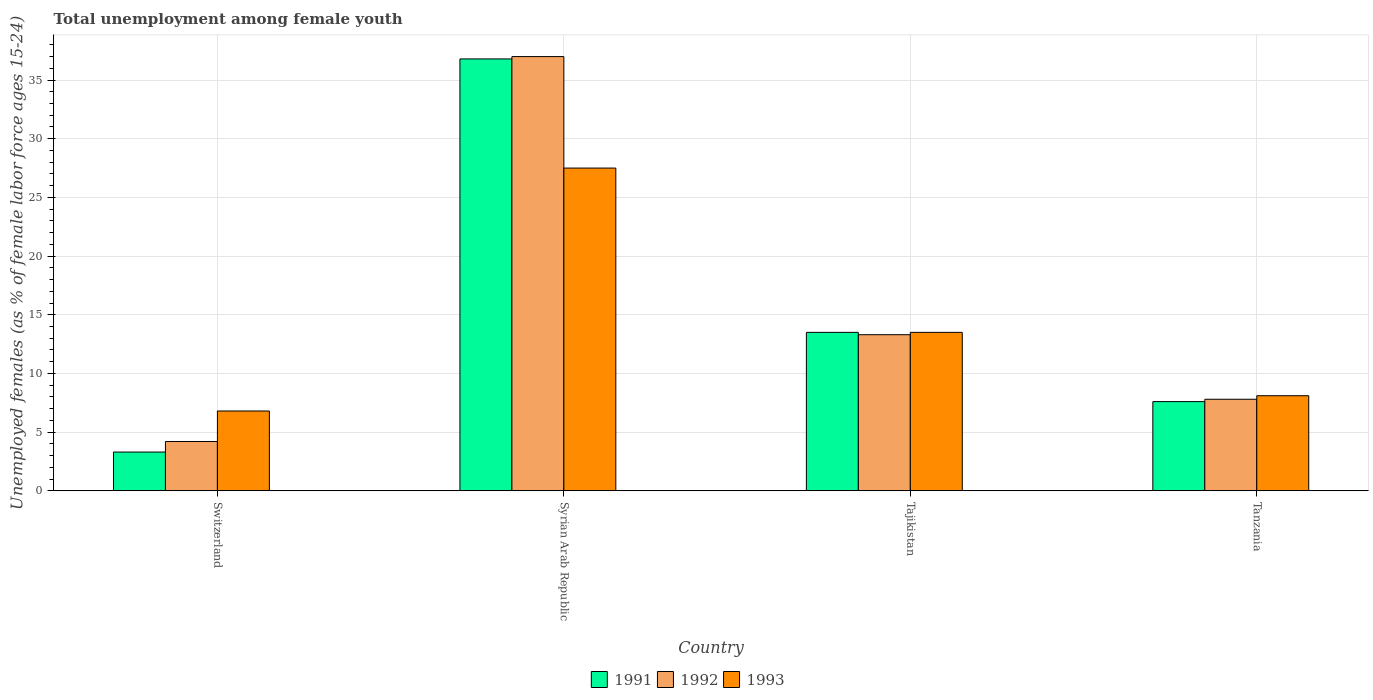How many different coloured bars are there?
Ensure brevity in your answer.  3. How many groups of bars are there?
Make the answer very short. 4. Are the number of bars per tick equal to the number of legend labels?
Offer a terse response. Yes. Are the number of bars on each tick of the X-axis equal?
Your answer should be compact. Yes. How many bars are there on the 3rd tick from the left?
Keep it short and to the point. 3. How many bars are there on the 1st tick from the right?
Provide a short and direct response. 3. What is the label of the 4th group of bars from the left?
Ensure brevity in your answer.  Tanzania. In how many cases, is the number of bars for a given country not equal to the number of legend labels?
Provide a short and direct response. 0. What is the percentage of unemployed females in in 1992 in Tanzania?
Offer a very short reply. 7.8. Across all countries, what is the maximum percentage of unemployed females in in 1992?
Make the answer very short. 37. Across all countries, what is the minimum percentage of unemployed females in in 1991?
Give a very brief answer. 3.3. In which country was the percentage of unemployed females in in 1991 maximum?
Your answer should be very brief. Syrian Arab Republic. In which country was the percentage of unemployed females in in 1991 minimum?
Your answer should be compact. Switzerland. What is the total percentage of unemployed females in in 1992 in the graph?
Make the answer very short. 62.3. What is the difference between the percentage of unemployed females in in 1992 in Tajikistan and the percentage of unemployed females in in 1991 in Tanzania?
Your answer should be very brief. 5.7. What is the average percentage of unemployed females in in 1991 per country?
Offer a very short reply. 15.3. What is the difference between the percentage of unemployed females in of/in 1993 and percentage of unemployed females in of/in 1992 in Tanzania?
Ensure brevity in your answer.  0.3. What is the ratio of the percentage of unemployed females in in 1993 in Switzerland to that in Tajikistan?
Give a very brief answer. 0.5. Is the percentage of unemployed females in in 1992 in Syrian Arab Republic less than that in Tajikistan?
Offer a very short reply. No. What is the difference between the highest and the second highest percentage of unemployed females in in 1992?
Make the answer very short. -23.7. What is the difference between the highest and the lowest percentage of unemployed females in in 1991?
Ensure brevity in your answer.  33.5. In how many countries, is the percentage of unemployed females in in 1993 greater than the average percentage of unemployed females in in 1993 taken over all countries?
Offer a terse response. 1. Is the sum of the percentage of unemployed females in in 1992 in Switzerland and Syrian Arab Republic greater than the maximum percentage of unemployed females in in 1993 across all countries?
Offer a terse response. Yes. What does the 2nd bar from the left in Tanzania represents?
Provide a succinct answer. 1992. How many bars are there?
Offer a terse response. 12. Does the graph contain any zero values?
Provide a short and direct response. No. Where does the legend appear in the graph?
Make the answer very short. Bottom center. What is the title of the graph?
Offer a very short reply. Total unemployment among female youth. Does "2013" appear as one of the legend labels in the graph?
Your answer should be very brief. No. What is the label or title of the X-axis?
Your response must be concise. Country. What is the label or title of the Y-axis?
Offer a very short reply. Unemployed females (as % of female labor force ages 15-24). What is the Unemployed females (as % of female labor force ages 15-24) in 1991 in Switzerland?
Ensure brevity in your answer.  3.3. What is the Unemployed females (as % of female labor force ages 15-24) in 1992 in Switzerland?
Keep it short and to the point. 4.2. What is the Unemployed females (as % of female labor force ages 15-24) in 1993 in Switzerland?
Offer a very short reply. 6.8. What is the Unemployed females (as % of female labor force ages 15-24) of 1991 in Syrian Arab Republic?
Your answer should be very brief. 36.8. What is the Unemployed females (as % of female labor force ages 15-24) in 1992 in Syrian Arab Republic?
Your answer should be compact. 37. What is the Unemployed females (as % of female labor force ages 15-24) in 1991 in Tajikistan?
Offer a terse response. 13.5. What is the Unemployed females (as % of female labor force ages 15-24) of 1992 in Tajikistan?
Make the answer very short. 13.3. What is the Unemployed females (as % of female labor force ages 15-24) in 1991 in Tanzania?
Your response must be concise. 7.6. What is the Unemployed females (as % of female labor force ages 15-24) in 1992 in Tanzania?
Your answer should be very brief. 7.8. What is the Unemployed females (as % of female labor force ages 15-24) of 1993 in Tanzania?
Your response must be concise. 8.1. Across all countries, what is the maximum Unemployed females (as % of female labor force ages 15-24) in 1991?
Provide a succinct answer. 36.8. Across all countries, what is the maximum Unemployed females (as % of female labor force ages 15-24) of 1992?
Ensure brevity in your answer.  37. Across all countries, what is the maximum Unemployed females (as % of female labor force ages 15-24) of 1993?
Offer a very short reply. 27.5. Across all countries, what is the minimum Unemployed females (as % of female labor force ages 15-24) of 1991?
Your answer should be compact. 3.3. Across all countries, what is the minimum Unemployed females (as % of female labor force ages 15-24) of 1992?
Offer a very short reply. 4.2. Across all countries, what is the minimum Unemployed females (as % of female labor force ages 15-24) in 1993?
Offer a very short reply. 6.8. What is the total Unemployed females (as % of female labor force ages 15-24) in 1991 in the graph?
Provide a short and direct response. 61.2. What is the total Unemployed females (as % of female labor force ages 15-24) of 1992 in the graph?
Offer a very short reply. 62.3. What is the total Unemployed females (as % of female labor force ages 15-24) of 1993 in the graph?
Your response must be concise. 55.9. What is the difference between the Unemployed females (as % of female labor force ages 15-24) of 1991 in Switzerland and that in Syrian Arab Republic?
Offer a terse response. -33.5. What is the difference between the Unemployed females (as % of female labor force ages 15-24) in 1992 in Switzerland and that in Syrian Arab Republic?
Offer a terse response. -32.8. What is the difference between the Unemployed females (as % of female labor force ages 15-24) in 1993 in Switzerland and that in Syrian Arab Republic?
Offer a very short reply. -20.7. What is the difference between the Unemployed females (as % of female labor force ages 15-24) of 1991 in Switzerland and that in Tajikistan?
Ensure brevity in your answer.  -10.2. What is the difference between the Unemployed females (as % of female labor force ages 15-24) of 1992 in Switzerland and that in Tajikistan?
Provide a succinct answer. -9.1. What is the difference between the Unemployed females (as % of female labor force ages 15-24) of 1993 in Switzerland and that in Tajikistan?
Your answer should be compact. -6.7. What is the difference between the Unemployed females (as % of female labor force ages 15-24) in 1991 in Switzerland and that in Tanzania?
Make the answer very short. -4.3. What is the difference between the Unemployed females (as % of female labor force ages 15-24) in 1992 in Switzerland and that in Tanzania?
Your answer should be compact. -3.6. What is the difference between the Unemployed females (as % of female labor force ages 15-24) of 1993 in Switzerland and that in Tanzania?
Provide a short and direct response. -1.3. What is the difference between the Unemployed females (as % of female labor force ages 15-24) in 1991 in Syrian Arab Republic and that in Tajikistan?
Keep it short and to the point. 23.3. What is the difference between the Unemployed females (as % of female labor force ages 15-24) in 1992 in Syrian Arab Republic and that in Tajikistan?
Provide a short and direct response. 23.7. What is the difference between the Unemployed females (as % of female labor force ages 15-24) of 1991 in Syrian Arab Republic and that in Tanzania?
Provide a succinct answer. 29.2. What is the difference between the Unemployed females (as % of female labor force ages 15-24) of 1992 in Syrian Arab Republic and that in Tanzania?
Give a very brief answer. 29.2. What is the difference between the Unemployed females (as % of female labor force ages 15-24) in 1991 in Tajikistan and that in Tanzania?
Keep it short and to the point. 5.9. What is the difference between the Unemployed females (as % of female labor force ages 15-24) of 1992 in Tajikistan and that in Tanzania?
Your answer should be compact. 5.5. What is the difference between the Unemployed females (as % of female labor force ages 15-24) of 1991 in Switzerland and the Unemployed females (as % of female labor force ages 15-24) of 1992 in Syrian Arab Republic?
Provide a succinct answer. -33.7. What is the difference between the Unemployed females (as % of female labor force ages 15-24) of 1991 in Switzerland and the Unemployed females (as % of female labor force ages 15-24) of 1993 in Syrian Arab Republic?
Your answer should be compact. -24.2. What is the difference between the Unemployed females (as % of female labor force ages 15-24) in 1992 in Switzerland and the Unemployed females (as % of female labor force ages 15-24) in 1993 in Syrian Arab Republic?
Offer a terse response. -23.3. What is the difference between the Unemployed females (as % of female labor force ages 15-24) in 1991 in Switzerland and the Unemployed females (as % of female labor force ages 15-24) in 1992 in Tajikistan?
Ensure brevity in your answer.  -10. What is the difference between the Unemployed females (as % of female labor force ages 15-24) in 1991 in Switzerland and the Unemployed females (as % of female labor force ages 15-24) in 1993 in Tajikistan?
Give a very brief answer. -10.2. What is the difference between the Unemployed females (as % of female labor force ages 15-24) of 1991 in Switzerland and the Unemployed females (as % of female labor force ages 15-24) of 1992 in Tanzania?
Provide a succinct answer. -4.5. What is the difference between the Unemployed females (as % of female labor force ages 15-24) of 1991 in Switzerland and the Unemployed females (as % of female labor force ages 15-24) of 1993 in Tanzania?
Your response must be concise. -4.8. What is the difference between the Unemployed females (as % of female labor force ages 15-24) in 1991 in Syrian Arab Republic and the Unemployed females (as % of female labor force ages 15-24) in 1992 in Tajikistan?
Your answer should be very brief. 23.5. What is the difference between the Unemployed females (as % of female labor force ages 15-24) of 1991 in Syrian Arab Republic and the Unemployed females (as % of female labor force ages 15-24) of 1993 in Tajikistan?
Keep it short and to the point. 23.3. What is the difference between the Unemployed females (as % of female labor force ages 15-24) in 1991 in Syrian Arab Republic and the Unemployed females (as % of female labor force ages 15-24) in 1993 in Tanzania?
Keep it short and to the point. 28.7. What is the difference between the Unemployed females (as % of female labor force ages 15-24) of 1992 in Syrian Arab Republic and the Unemployed females (as % of female labor force ages 15-24) of 1993 in Tanzania?
Your answer should be compact. 28.9. What is the difference between the Unemployed females (as % of female labor force ages 15-24) in 1991 in Tajikistan and the Unemployed females (as % of female labor force ages 15-24) in 1992 in Tanzania?
Ensure brevity in your answer.  5.7. What is the difference between the Unemployed females (as % of female labor force ages 15-24) of 1991 in Tajikistan and the Unemployed females (as % of female labor force ages 15-24) of 1993 in Tanzania?
Your answer should be compact. 5.4. What is the difference between the Unemployed females (as % of female labor force ages 15-24) in 1992 in Tajikistan and the Unemployed females (as % of female labor force ages 15-24) in 1993 in Tanzania?
Give a very brief answer. 5.2. What is the average Unemployed females (as % of female labor force ages 15-24) of 1991 per country?
Offer a terse response. 15.3. What is the average Unemployed females (as % of female labor force ages 15-24) of 1992 per country?
Provide a short and direct response. 15.57. What is the average Unemployed females (as % of female labor force ages 15-24) in 1993 per country?
Provide a short and direct response. 13.97. What is the difference between the Unemployed females (as % of female labor force ages 15-24) of 1991 and Unemployed females (as % of female labor force ages 15-24) of 1993 in Switzerland?
Keep it short and to the point. -3.5. What is the difference between the Unemployed females (as % of female labor force ages 15-24) of 1991 and Unemployed females (as % of female labor force ages 15-24) of 1993 in Syrian Arab Republic?
Make the answer very short. 9.3. What is the difference between the Unemployed females (as % of female labor force ages 15-24) of 1991 and Unemployed females (as % of female labor force ages 15-24) of 1992 in Tajikistan?
Offer a terse response. 0.2. What is the difference between the Unemployed females (as % of female labor force ages 15-24) of 1991 and Unemployed females (as % of female labor force ages 15-24) of 1993 in Tajikistan?
Your answer should be compact. 0. What is the difference between the Unemployed females (as % of female labor force ages 15-24) in 1992 and Unemployed females (as % of female labor force ages 15-24) in 1993 in Tajikistan?
Provide a short and direct response. -0.2. What is the difference between the Unemployed females (as % of female labor force ages 15-24) of 1991 and Unemployed females (as % of female labor force ages 15-24) of 1993 in Tanzania?
Give a very brief answer. -0.5. What is the ratio of the Unemployed females (as % of female labor force ages 15-24) of 1991 in Switzerland to that in Syrian Arab Republic?
Offer a terse response. 0.09. What is the ratio of the Unemployed females (as % of female labor force ages 15-24) of 1992 in Switzerland to that in Syrian Arab Republic?
Give a very brief answer. 0.11. What is the ratio of the Unemployed females (as % of female labor force ages 15-24) of 1993 in Switzerland to that in Syrian Arab Republic?
Provide a short and direct response. 0.25. What is the ratio of the Unemployed females (as % of female labor force ages 15-24) in 1991 in Switzerland to that in Tajikistan?
Offer a very short reply. 0.24. What is the ratio of the Unemployed females (as % of female labor force ages 15-24) of 1992 in Switzerland to that in Tajikistan?
Your response must be concise. 0.32. What is the ratio of the Unemployed females (as % of female labor force ages 15-24) in 1993 in Switzerland to that in Tajikistan?
Offer a terse response. 0.5. What is the ratio of the Unemployed females (as % of female labor force ages 15-24) of 1991 in Switzerland to that in Tanzania?
Give a very brief answer. 0.43. What is the ratio of the Unemployed females (as % of female labor force ages 15-24) in 1992 in Switzerland to that in Tanzania?
Ensure brevity in your answer.  0.54. What is the ratio of the Unemployed females (as % of female labor force ages 15-24) in 1993 in Switzerland to that in Tanzania?
Provide a succinct answer. 0.84. What is the ratio of the Unemployed females (as % of female labor force ages 15-24) of 1991 in Syrian Arab Republic to that in Tajikistan?
Make the answer very short. 2.73. What is the ratio of the Unemployed females (as % of female labor force ages 15-24) of 1992 in Syrian Arab Republic to that in Tajikistan?
Offer a very short reply. 2.78. What is the ratio of the Unemployed females (as % of female labor force ages 15-24) of 1993 in Syrian Arab Republic to that in Tajikistan?
Offer a very short reply. 2.04. What is the ratio of the Unemployed females (as % of female labor force ages 15-24) of 1991 in Syrian Arab Republic to that in Tanzania?
Provide a succinct answer. 4.84. What is the ratio of the Unemployed females (as % of female labor force ages 15-24) in 1992 in Syrian Arab Republic to that in Tanzania?
Your answer should be very brief. 4.74. What is the ratio of the Unemployed females (as % of female labor force ages 15-24) of 1993 in Syrian Arab Republic to that in Tanzania?
Make the answer very short. 3.4. What is the ratio of the Unemployed females (as % of female labor force ages 15-24) of 1991 in Tajikistan to that in Tanzania?
Offer a terse response. 1.78. What is the ratio of the Unemployed females (as % of female labor force ages 15-24) in 1992 in Tajikistan to that in Tanzania?
Keep it short and to the point. 1.71. What is the ratio of the Unemployed females (as % of female labor force ages 15-24) in 1993 in Tajikistan to that in Tanzania?
Provide a short and direct response. 1.67. What is the difference between the highest and the second highest Unemployed females (as % of female labor force ages 15-24) in 1991?
Keep it short and to the point. 23.3. What is the difference between the highest and the second highest Unemployed females (as % of female labor force ages 15-24) of 1992?
Provide a short and direct response. 23.7. What is the difference between the highest and the second highest Unemployed females (as % of female labor force ages 15-24) in 1993?
Make the answer very short. 14. What is the difference between the highest and the lowest Unemployed females (as % of female labor force ages 15-24) in 1991?
Provide a succinct answer. 33.5. What is the difference between the highest and the lowest Unemployed females (as % of female labor force ages 15-24) in 1992?
Your answer should be very brief. 32.8. What is the difference between the highest and the lowest Unemployed females (as % of female labor force ages 15-24) of 1993?
Ensure brevity in your answer.  20.7. 